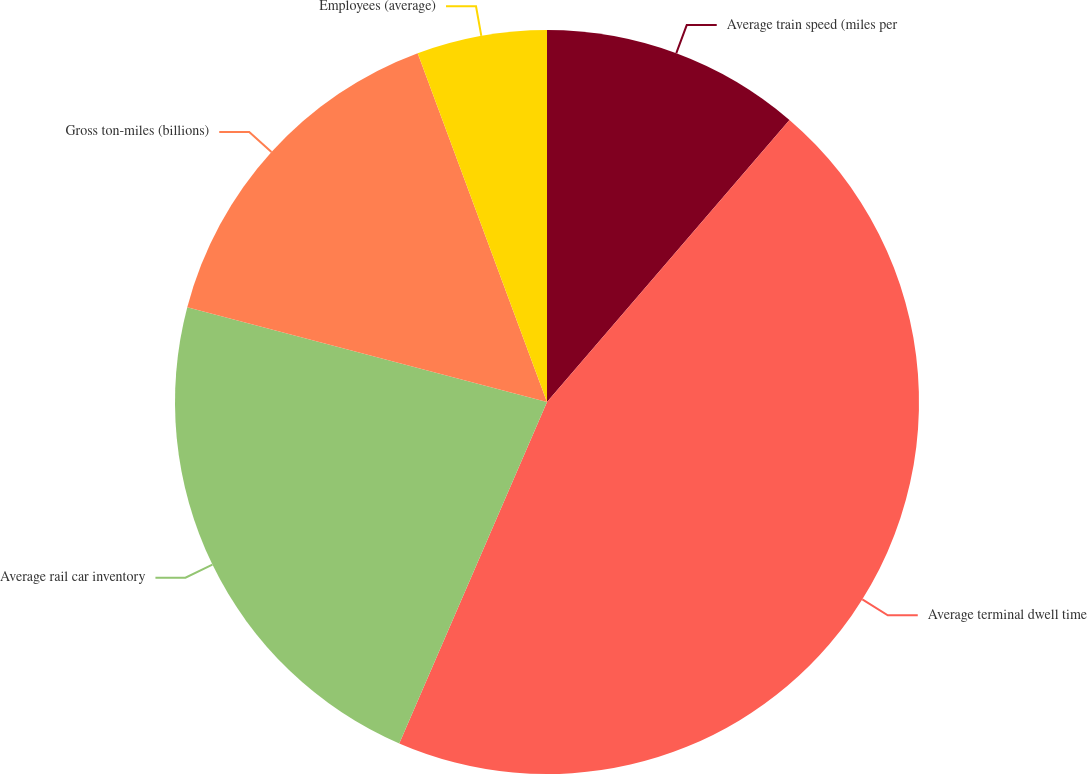Convert chart. <chart><loc_0><loc_0><loc_500><loc_500><pie_chart><fcel>Average train speed (miles per<fcel>Average terminal dwell time<fcel>Average rail car inventory<fcel>Gross ton-miles (billions)<fcel>Employees (average)<nl><fcel>11.3%<fcel>45.2%<fcel>22.6%<fcel>15.25%<fcel>5.65%<nl></chart> 